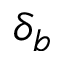Convert formula to latex. <formula><loc_0><loc_0><loc_500><loc_500>\delta _ { b }</formula> 